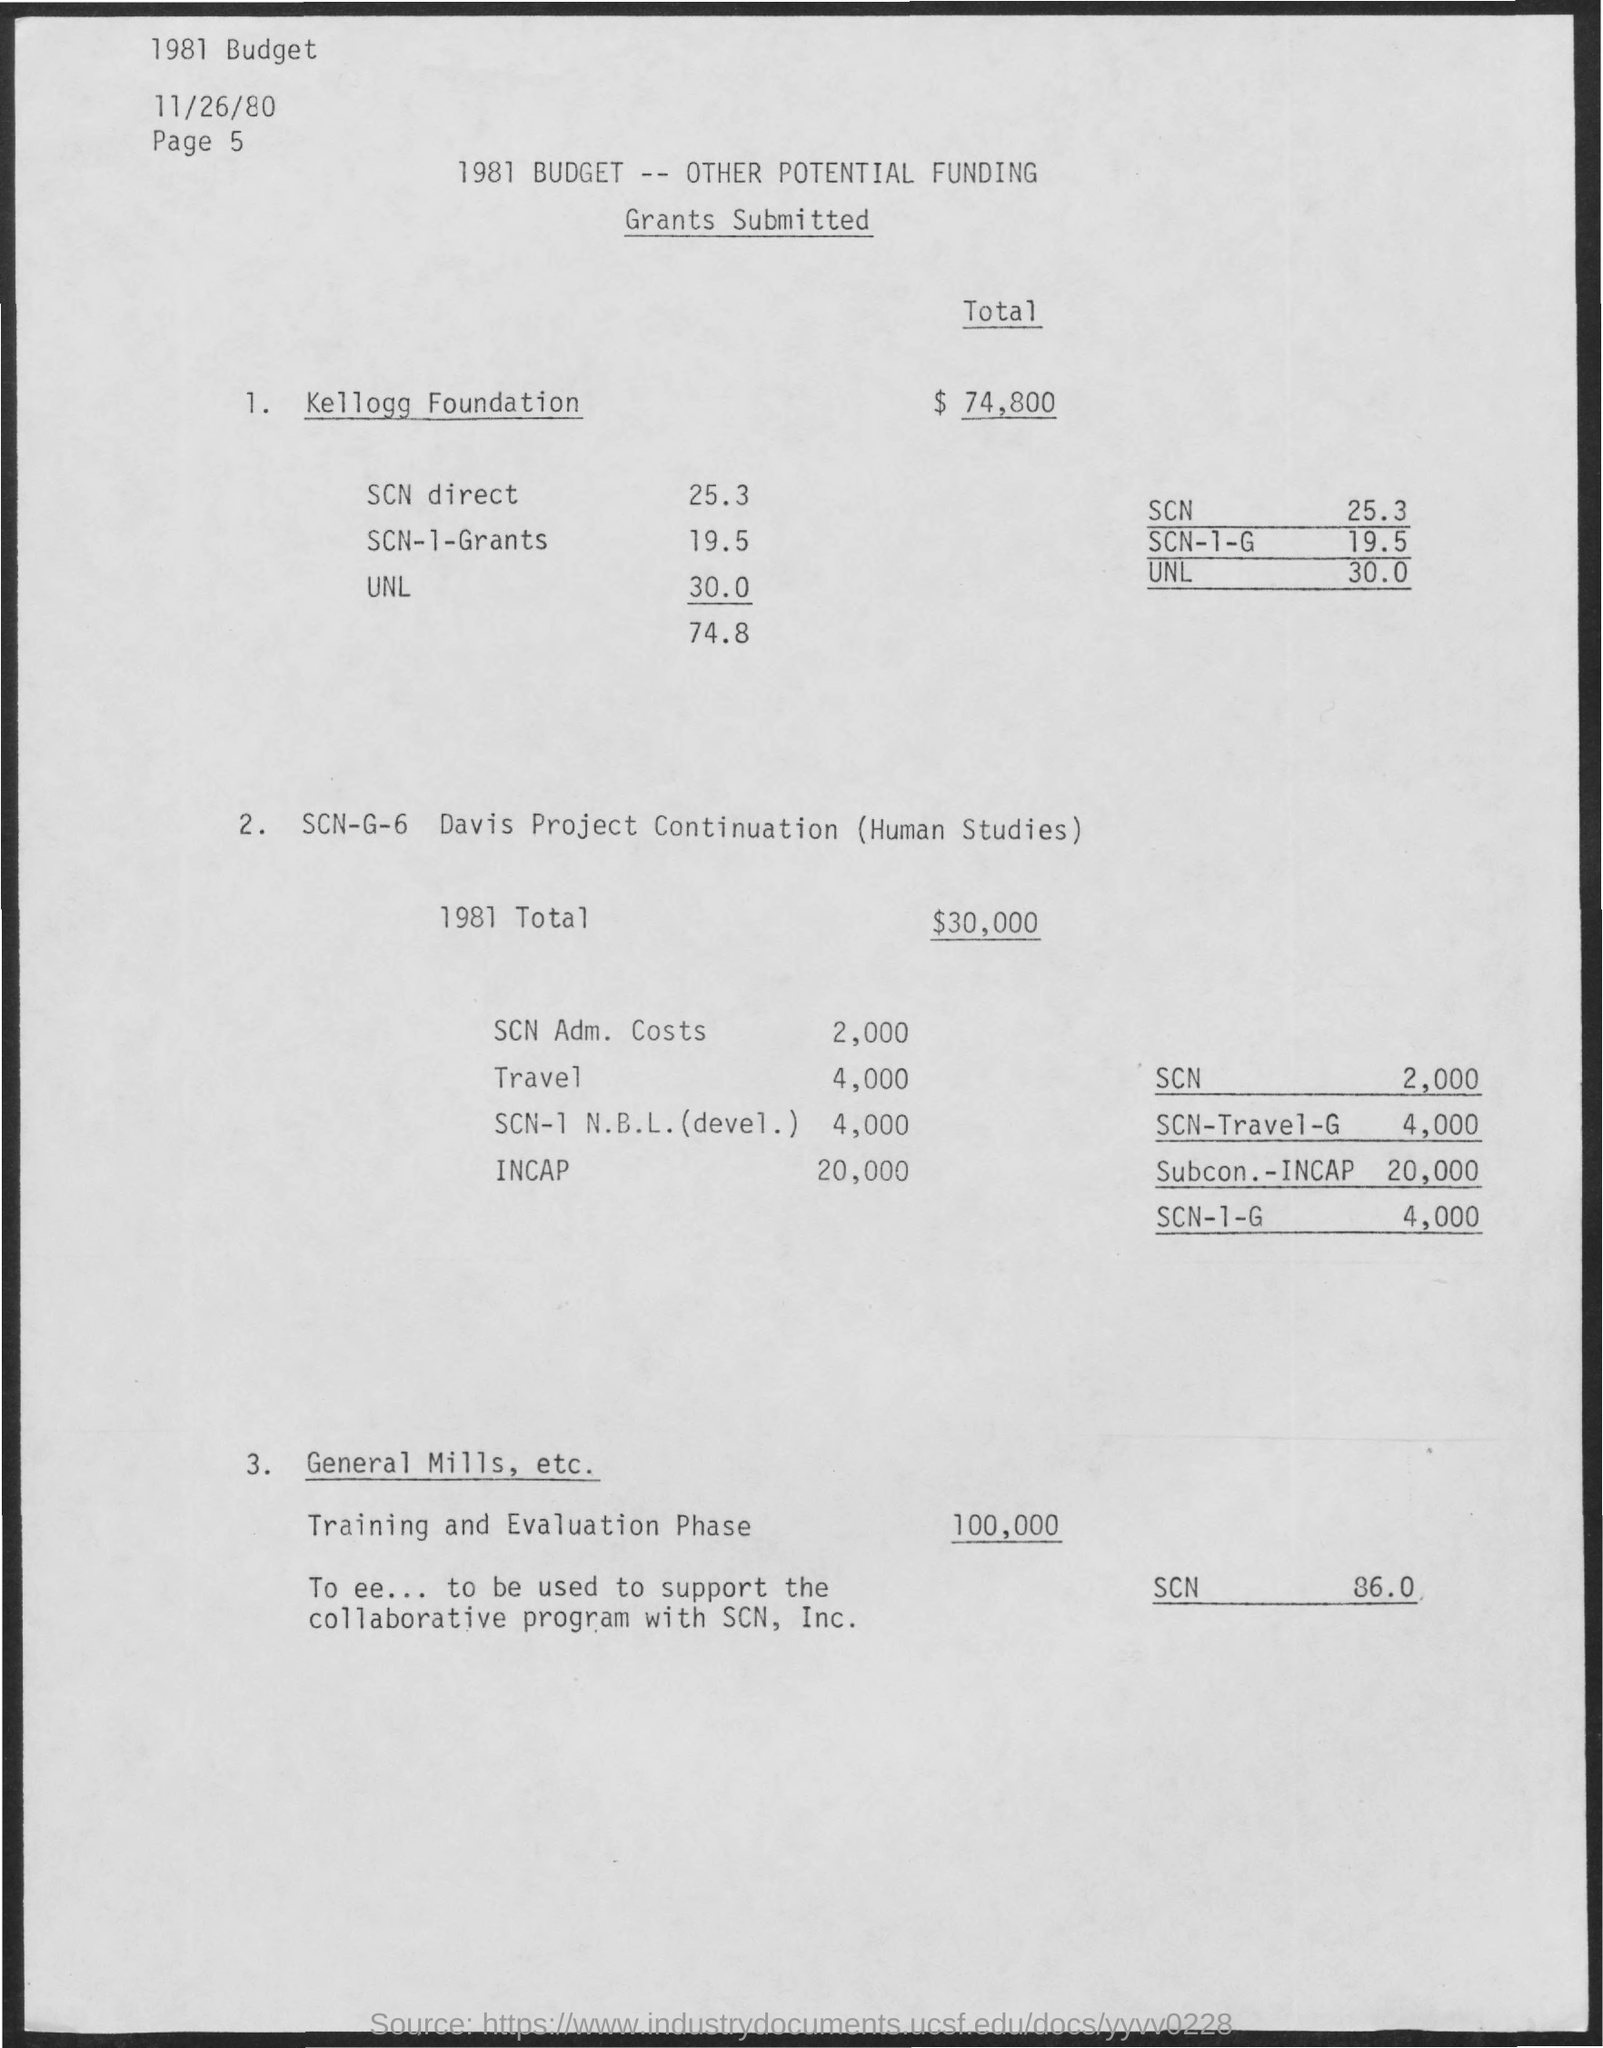Draw attention to some important aspects in this diagram. The total fund for the training and evaluation phase is 100,000. 